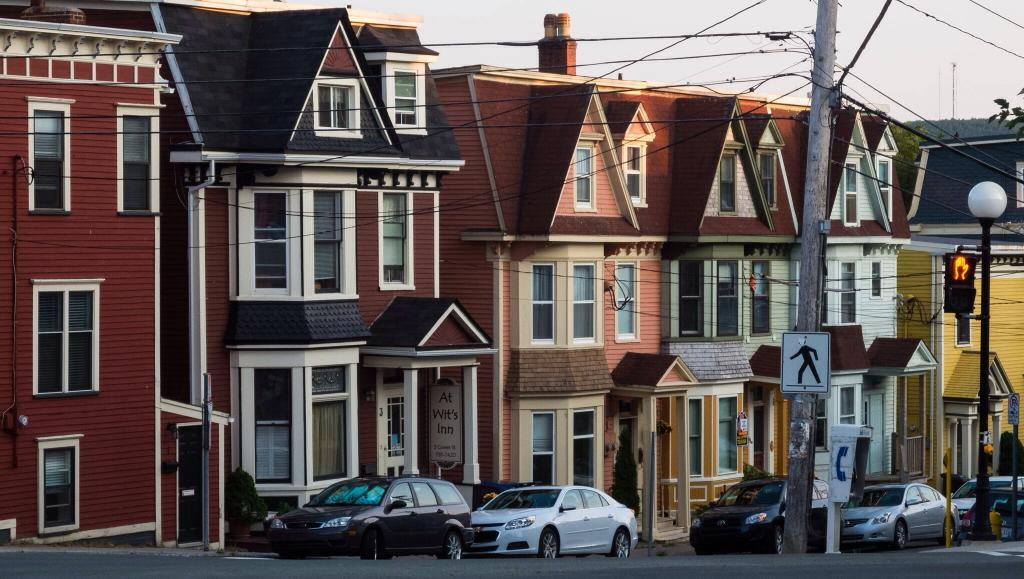What type of structures can be seen in the image? There are houses with windows in the image. What is happening on the road in the image? There are vehicles on the road in the image. What objects are present in the image that are used for support or attachment? There are poles, boards, and cables in the image. What type of natural elements can be seen in the image? There are trees in the image. What is visible in the background of the image? The sky is visible in the background of the image. Where is the playground located in the image? There is no playground present in the image. What type of recess can be seen in the image? There is no recess present in the image. 